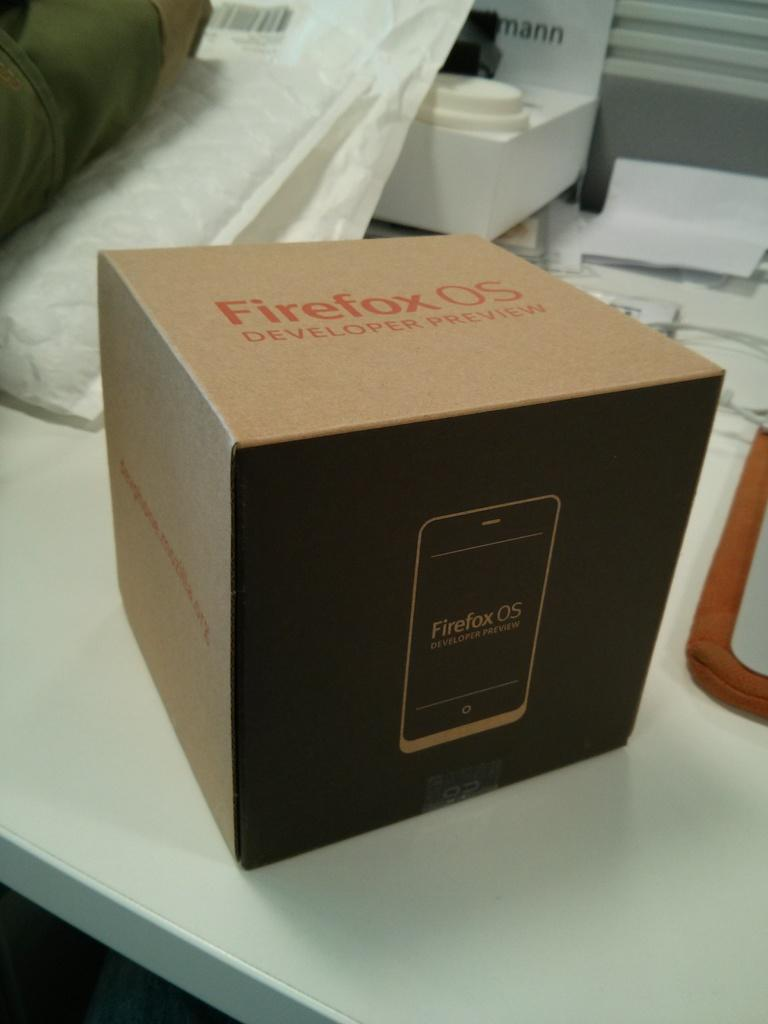<image>
Present a compact description of the photo's key features. A box from Firefox has a picture of a cell phone on it. 